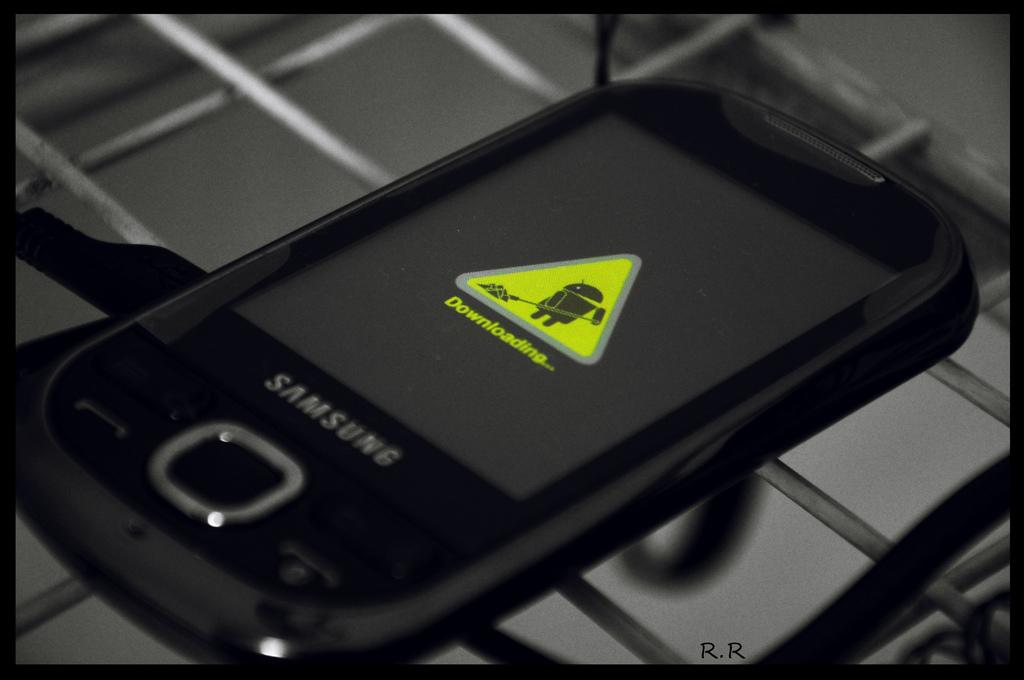<image>
Present a compact description of the photo's key features. The front of a Samsung phone indicates that it is downloading something. 